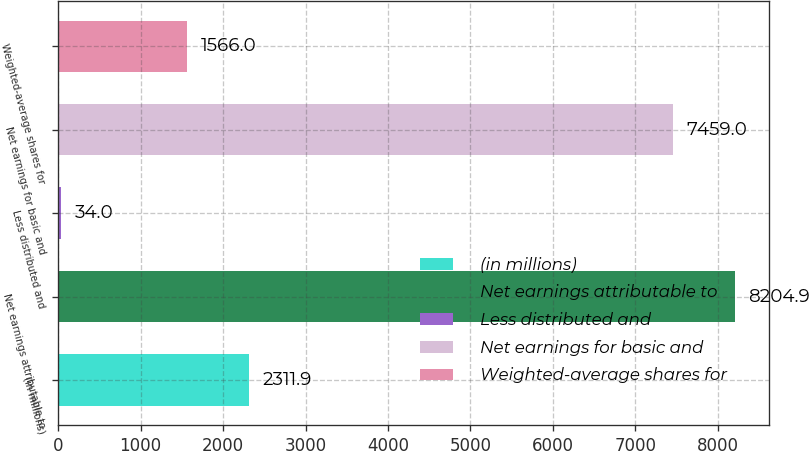Convert chart. <chart><loc_0><loc_0><loc_500><loc_500><bar_chart><fcel>(in millions)<fcel>Net earnings attributable to<fcel>Less distributed and<fcel>Net earnings for basic and<fcel>Weighted-average shares for<nl><fcel>2311.9<fcel>8204.9<fcel>34<fcel>7459<fcel>1566<nl></chart> 